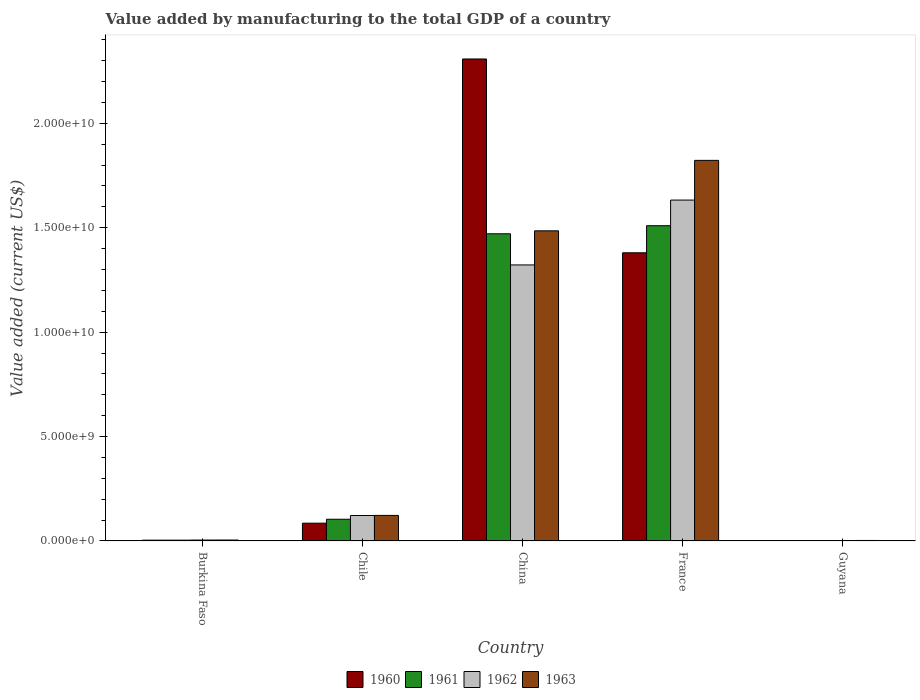How many different coloured bars are there?
Offer a terse response. 4. How many bars are there on the 5th tick from the left?
Your response must be concise. 4. How many bars are there on the 5th tick from the right?
Make the answer very short. 4. What is the label of the 1st group of bars from the left?
Provide a short and direct response. Burkina Faso. What is the value added by manufacturing to the total GDP in 1962 in Chile?
Your answer should be very brief. 1.22e+09. Across all countries, what is the maximum value added by manufacturing to the total GDP in 1963?
Your response must be concise. 1.82e+1. Across all countries, what is the minimum value added by manufacturing to the total GDP in 1963?
Provide a succinct answer. 2.32e+07. In which country was the value added by manufacturing to the total GDP in 1962 minimum?
Provide a short and direct response. Guyana. What is the total value added by manufacturing to the total GDP in 1960 in the graph?
Make the answer very short. 3.78e+1. What is the difference between the value added by manufacturing to the total GDP in 1960 in China and that in France?
Ensure brevity in your answer.  9.28e+09. What is the difference between the value added by manufacturing to the total GDP in 1961 in France and the value added by manufacturing to the total GDP in 1960 in China?
Ensure brevity in your answer.  -7.98e+09. What is the average value added by manufacturing to the total GDP in 1961 per country?
Keep it short and to the point. 6.18e+09. What is the difference between the value added by manufacturing to the total GDP of/in 1963 and value added by manufacturing to the total GDP of/in 1962 in Chile?
Offer a very short reply. 4.28e+06. In how many countries, is the value added by manufacturing to the total GDP in 1962 greater than 1000000000 US$?
Your answer should be very brief. 3. What is the ratio of the value added by manufacturing to the total GDP in 1963 in Chile to that in China?
Your answer should be compact. 0.08. What is the difference between the highest and the second highest value added by manufacturing to the total GDP in 1961?
Provide a succinct answer. -3.87e+08. What is the difference between the highest and the lowest value added by manufacturing to the total GDP in 1962?
Offer a terse response. 1.63e+1. In how many countries, is the value added by manufacturing to the total GDP in 1960 greater than the average value added by manufacturing to the total GDP in 1960 taken over all countries?
Keep it short and to the point. 2. Is the sum of the value added by manufacturing to the total GDP in 1963 in Chile and China greater than the maximum value added by manufacturing to the total GDP in 1960 across all countries?
Give a very brief answer. No. What does the 3rd bar from the right in Chile represents?
Your answer should be compact. 1961. How many bars are there?
Give a very brief answer. 20. Does the graph contain grids?
Provide a short and direct response. No. Where does the legend appear in the graph?
Ensure brevity in your answer.  Bottom center. What is the title of the graph?
Ensure brevity in your answer.  Value added by manufacturing to the total GDP of a country. What is the label or title of the X-axis?
Give a very brief answer. Country. What is the label or title of the Y-axis?
Give a very brief answer. Value added (current US$). What is the Value added (current US$) of 1960 in Burkina Faso?
Your answer should be very brief. 3.72e+07. What is the Value added (current US$) in 1961 in Burkina Faso?
Your response must be concise. 3.72e+07. What is the Value added (current US$) in 1962 in Burkina Faso?
Ensure brevity in your answer.  4.22e+07. What is the Value added (current US$) in 1963 in Burkina Faso?
Keep it short and to the point. 4.39e+07. What is the Value added (current US$) in 1960 in Chile?
Offer a terse response. 8.51e+08. What is the Value added (current US$) of 1961 in Chile?
Offer a terse response. 1.04e+09. What is the Value added (current US$) of 1962 in Chile?
Ensure brevity in your answer.  1.22e+09. What is the Value added (current US$) in 1963 in Chile?
Keep it short and to the point. 1.22e+09. What is the Value added (current US$) of 1960 in China?
Ensure brevity in your answer.  2.31e+1. What is the Value added (current US$) in 1961 in China?
Offer a very short reply. 1.47e+1. What is the Value added (current US$) in 1962 in China?
Ensure brevity in your answer.  1.32e+1. What is the Value added (current US$) in 1963 in China?
Provide a short and direct response. 1.49e+1. What is the Value added (current US$) in 1960 in France?
Offer a very short reply. 1.38e+1. What is the Value added (current US$) in 1961 in France?
Provide a short and direct response. 1.51e+1. What is the Value added (current US$) in 1962 in France?
Your answer should be very brief. 1.63e+1. What is the Value added (current US$) of 1963 in France?
Your answer should be very brief. 1.82e+1. What is the Value added (current US$) of 1960 in Guyana?
Your response must be concise. 1.59e+07. What is the Value added (current US$) of 1961 in Guyana?
Provide a succinct answer. 1.84e+07. What is the Value added (current US$) of 1962 in Guyana?
Your answer should be very brief. 2.08e+07. What is the Value added (current US$) of 1963 in Guyana?
Your answer should be compact. 2.32e+07. Across all countries, what is the maximum Value added (current US$) in 1960?
Your response must be concise. 2.31e+1. Across all countries, what is the maximum Value added (current US$) of 1961?
Give a very brief answer. 1.51e+1. Across all countries, what is the maximum Value added (current US$) in 1962?
Ensure brevity in your answer.  1.63e+1. Across all countries, what is the maximum Value added (current US$) of 1963?
Keep it short and to the point. 1.82e+1. Across all countries, what is the minimum Value added (current US$) in 1960?
Offer a terse response. 1.59e+07. Across all countries, what is the minimum Value added (current US$) in 1961?
Give a very brief answer. 1.84e+07. Across all countries, what is the minimum Value added (current US$) in 1962?
Keep it short and to the point. 2.08e+07. Across all countries, what is the minimum Value added (current US$) in 1963?
Your answer should be compact. 2.32e+07. What is the total Value added (current US$) in 1960 in the graph?
Provide a short and direct response. 3.78e+1. What is the total Value added (current US$) in 1961 in the graph?
Offer a very short reply. 3.09e+1. What is the total Value added (current US$) of 1962 in the graph?
Ensure brevity in your answer.  3.08e+1. What is the total Value added (current US$) of 1963 in the graph?
Provide a succinct answer. 3.44e+1. What is the difference between the Value added (current US$) in 1960 in Burkina Faso and that in Chile?
Offer a very short reply. -8.13e+08. What is the difference between the Value added (current US$) in 1961 in Burkina Faso and that in Chile?
Keep it short and to the point. -1.00e+09. What is the difference between the Value added (current US$) in 1962 in Burkina Faso and that in Chile?
Provide a succinct answer. -1.18e+09. What is the difference between the Value added (current US$) of 1963 in Burkina Faso and that in Chile?
Your answer should be compact. -1.18e+09. What is the difference between the Value added (current US$) of 1960 in Burkina Faso and that in China?
Provide a short and direct response. -2.30e+1. What is the difference between the Value added (current US$) in 1961 in Burkina Faso and that in China?
Provide a succinct answer. -1.47e+1. What is the difference between the Value added (current US$) in 1962 in Burkina Faso and that in China?
Provide a short and direct response. -1.32e+1. What is the difference between the Value added (current US$) of 1963 in Burkina Faso and that in China?
Your answer should be compact. -1.48e+1. What is the difference between the Value added (current US$) in 1960 in Burkina Faso and that in France?
Provide a succinct answer. -1.38e+1. What is the difference between the Value added (current US$) of 1961 in Burkina Faso and that in France?
Your answer should be very brief. -1.51e+1. What is the difference between the Value added (current US$) in 1962 in Burkina Faso and that in France?
Ensure brevity in your answer.  -1.63e+1. What is the difference between the Value added (current US$) of 1963 in Burkina Faso and that in France?
Provide a succinct answer. -1.82e+1. What is the difference between the Value added (current US$) of 1960 in Burkina Faso and that in Guyana?
Your answer should be compact. 2.14e+07. What is the difference between the Value added (current US$) of 1961 in Burkina Faso and that in Guyana?
Give a very brief answer. 1.88e+07. What is the difference between the Value added (current US$) in 1962 in Burkina Faso and that in Guyana?
Offer a terse response. 2.15e+07. What is the difference between the Value added (current US$) in 1963 in Burkina Faso and that in Guyana?
Ensure brevity in your answer.  2.07e+07. What is the difference between the Value added (current US$) of 1960 in Chile and that in China?
Provide a succinct answer. -2.22e+1. What is the difference between the Value added (current US$) of 1961 in Chile and that in China?
Your answer should be very brief. -1.37e+1. What is the difference between the Value added (current US$) of 1962 in Chile and that in China?
Your answer should be very brief. -1.20e+1. What is the difference between the Value added (current US$) of 1963 in Chile and that in China?
Your answer should be very brief. -1.36e+1. What is the difference between the Value added (current US$) in 1960 in Chile and that in France?
Ensure brevity in your answer.  -1.29e+1. What is the difference between the Value added (current US$) in 1961 in Chile and that in France?
Provide a short and direct response. -1.41e+1. What is the difference between the Value added (current US$) of 1962 in Chile and that in France?
Offer a terse response. -1.51e+1. What is the difference between the Value added (current US$) of 1963 in Chile and that in France?
Your answer should be very brief. -1.70e+1. What is the difference between the Value added (current US$) in 1960 in Chile and that in Guyana?
Give a very brief answer. 8.35e+08. What is the difference between the Value added (current US$) in 1961 in Chile and that in Guyana?
Give a very brief answer. 1.02e+09. What is the difference between the Value added (current US$) in 1962 in Chile and that in Guyana?
Offer a very short reply. 1.20e+09. What is the difference between the Value added (current US$) in 1963 in Chile and that in Guyana?
Your response must be concise. 1.20e+09. What is the difference between the Value added (current US$) in 1960 in China and that in France?
Provide a short and direct response. 9.28e+09. What is the difference between the Value added (current US$) of 1961 in China and that in France?
Provide a short and direct response. -3.87e+08. What is the difference between the Value added (current US$) of 1962 in China and that in France?
Your response must be concise. -3.11e+09. What is the difference between the Value added (current US$) in 1963 in China and that in France?
Ensure brevity in your answer.  -3.37e+09. What is the difference between the Value added (current US$) of 1960 in China and that in Guyana?
Your response must be concise. 2.31e+1. What is the difference between the Value added (current US$) of 1961 in China and that in Guyana?
Make the answer very short. 1.47e+1. What is the difference between the Value added (current US$) of 1962 in China and that in Guyana?
Keep it short and to the point. 1.32e+1. What is the difference between the Value added (current US$) of 1963 in China and that in Guyana?
Offer a terse response. 1.48e+1. What is the difference between the Value added (current US$) of 1960 in France and that in Guyana?
Provide a short and direct response. 1.38e+1. What is the difference between the Value added (current US$) in 1961 in France and that in Guyana?
Your answer should be compact. 1.51e+1. What is the difference between the Value added (current US$) in 1962 in France and that in Guyana?
Your answer should be compact. 1.63e+1. What is the difference between the Value added (current US$) in 1963 in France and that in Guyana?
Keep it short and to the point. 1.82e+1. What is the difference between the Value added (current US$) in 1960 in Burkina Faso and the Value added (current US$) in 1961 in Chile?
Ensure brevity in your answer.  -1.00e+09. What is the difference between the Value added (current US$) of 1960 in Burkina Faso and the Value added (current US$) of 1962 in Chile?
Provide a short and direct response. -1.18e+09. What is the difference between the Value added (current US$) in 1960 in Burkina Faso and the Value added (current US$) in 1963 in Chile?
Keep it short and to the point. -1.19e+09. What is the difference between the Value added (current US$) in 1961 in Burkina Faso and the Value added (current US$) in 1962 in Chile?
Provide a short and direct response. -1.18e+09. What is the difference between the Value added (current US$) in 1961 in Burkina Faso and the Value added (current US$) in 1963 in Chile?
Offer a very short reply. -1.19e+09. What is the difference between the Value added (current US$) of 1962 in Burkina Faso and the Value added (current US$) of 1963 in Chile?
Your answer should be very brief. -1.18e+09. What is the difference between the Value added (current US$) in 1960 in Burkina Faso and the Value added (current US$) in 1961 in China?
Provide a succinct answer. -1.47e+1. What is the difference between the Value added (current US$) of 1960 in Burkina Faso and the Value added (current US$) of 1962 in China?
Provide a short and direct response. -1.32e+1. What is the difference between the Value added (current US$) of 1960 in Burkina Faso and the Value added (current US$) of 1963 in China?
Give a very brief answer. -1.48e+1. What is the difference between the Value added (current US$) in 1961 in Burkina Faso and the Value added (current US$) in 1962 in China?
Offer a very short reply. -1.32e+1. What is the difference between the Value added (current US$) of 1961 in Burkina Faso and the Value added (current US$) of 1963 in China?
Provide a succinct answer. -1.48e+1. What is the difference between the Value added (current US$) of 1962 in Burkina Faso and the Value added (current US$) of 1963 in China?
Your response must be concise. -1.48e+1. What is the difference between the Value added (current US$) of 1960 in Burkina Faso and the Value added (current US$) of 1961 in France?
Make the answer very short. -1.51e+1. What is the difference between the Value added (current US$) in 1960 in Burkina Faso and the Value added (current US$) in 1962 in France?
Ensure brevity in your answer.  -1.63e+1. What is the difference between the Value added (current US$) of 1960 in Burkina Faso and the Value added (current US$) of 1963 in France?
Ensure brevity in your answer.  -1.82e+1. What is the difference between the Value added (current US$) in 1961 in Burkina Faso and the Value added (current US$) in 1962 in France?
Give a very brief answer. -1.63e+1. What is the difference between the Value added (current US$) of 1961 in Burkina Faso and the Value added (current US$) of 1963 in France?
Provide a short and direct response. -1.82e+1. What is the difference between the Value added (current US$) of 1962 in Burkina Faso and the Value added (current US$) of 1963 in France?
Your answer should be compact. -1.82e+1. What is the difference between the Value added (current US$) of 1960 in Burkina Faso and the Value added (current US$) of 1961 in Guyana?
Offer a very short reply. 1.89e+07. What is the difference between the Value added (current US$) of 1960 in Burkina Faso and the Value added (current US$) of 1962 in Guyana?
Your answer should be compact. 1.65e+07. What is the difference between the Value added (current US$) of 1960 in Burkina Faso and the Value added (current US$) of 1963 in Guyana?
Provide a succinct answer. 1.41e+07. What is the difference between the Value added (current US$) in 1961 in Burkina Faso and the Value added (current US$) in 1962 in Guyana?
Provide a short and direct response. 1.65e+07. What is the difference between the Value added (current US$) of 1961 in Burkina Faso and the Value added (current US$) of 1963 in Guyana?
Make the answer very short. 1.41e+07. What is the difference between the Value added (current US$) of 1962 in Burkina Faso and the Value added (current US$) of 1963 in Guyana?
Your response must be concise. 1.91e+07. What is the difference between the Value added (current US$) in 1960 in Chile and the Value added (current US$) in 1961 in China?
Your response must be concise. -1.39e+1. What is the difference between the Value added (current US$) in 1960 in Chile and the Value added (current US$) in 1962 in China?
Provide a succinct answer. -1.24e+1. What is the difference between the Value added (current US$) of 1960 in Chile and the Value added (current US$) of 1963 in China?
Your answer should be compact. -1.40e+1. What is the difference between the Value added (current US$) in 1961 in Chile and the Value added (current US$) in 1962 in China?
Offer a terse response. -1.22e+1. What is the difference between the Value added (current US$) in 1961 in Chile and the Value added (current US$) in 1963 in China?
Your response must be concise. -1.38e+1. What is the difference between the Value added (current US$) of 1962 in Chile and the Value added (current US$) of 1963 in China?
Give a very brief answer. -1.36e+1. What is the difference between the Value added (current US$) of 1960 in Chile and the Value added (current US$) of 1961 in France?
Your answer should be compact. -1.42e+1. What is the difference between the Value added (current US$) of 1960 in Chile and the Value added (current US$) of 1962 in France?
Keep it short and to the point. -1.55e+1. What is the difference between the Value added (current US$) in 1960 in Chile and the Value added (current US$) in 1963 in France?
Make the answer very short. -1.74e+1. What is the difference between the Value added (current US$) in 1961 in Chile and the Value added (current US$) in 1962 in France?
Keep it short and to the point. -1.53e+1. What is the difference between the Value added (current US$) of 1961 in Chile and the Value added (current US$) of 1963 in France?
Your answer should be very brief. -1.72e+1. What is the difference between the Value added (current US$) of 1962 in Chile and the Value added (current US$) of 1963 in France?
Provide a short and direct response. -1.70e+1. What is the difference between the Value added (current US$) in 1960 in Chile and the Value added (current US$) in 1961 in Guyana?
Provide a short and direct response. 8.32e+08. What is the difference between the Value added (current US$) of 1960 in Chile and the Value added (current US$) of 1962 in Guyana?
Your answer should be compact. 8.30e+08. What is the difference between the Value added (current US$) in 1960 in Chile and the Value added (current US$) in 1963 in Guyana?
Give a very brief answer. 8.28e+08. What is the difference between the Value added (current US$) of 1961 in Chile and the Value added (current US$) of 1962 in Guyana?
Your answer should be very brief. 1.02e+09. What is the difference between the Value added (current US$) of 1961 in Chile and the Value added (current US$) of 1963 in Guyana?
Your answer should be very brief. 1.02e+09. What is the difference between the Value added (current US$) in 1962 in Chile and the Value added (current US$) in 1963 in Guyana?
Provide a succinct answer. 1.20e+09. What is the difference between the Value added (current US$) of 1960 in China and the Value added (current US$) of 1961 in France?
Keep it short and to the point. 7.98e+09. What is the difference between the Value added (current US$) in 1960 in China and the Value added (current US$) in 1962 in France?
Provide a succinct answer. 6.76e+09. What is the difference between the Value added (current US$) of 1960 in China and the Value added (current US$) of 1963 in France?
Give a very brief answer. 4.86e+09. What is the difference between the Value added (current US$) in 1961 in China and the Value added (current US$) in 1962 in France?
Ensure brevity in your answer.  -1.61e+09. What is the difference between the Value added (current US$) in 1961 in China and the Value added (current US$) in 1963 in France?
Your answer should be compact. -3.52e+09. What is the difference between the Value added (current US$) in 1962 in China and the Value added (current US$) in 1963 in France?
Provide a short and direct response. -5.01e+09. What is the difference between the Value added (current US$) of 1960 in China and the Value added (current US$) of 1961 in Guyana?
Keep it short and to the point. 2.31e+1. What is the difference between the Value added (current US$) of 1960 in China and the Value added (current US$) of 1962 in Guyana?
Provide a succinct answer. 2.31e+1. What is the difference between the Value added (current US$) of 1960 in China and the Value added (current US$) of 1963 in Guyana?
Keep it short and to the point. 2.31e+1. What is the difference between the Value added (current US$) of 1961 in China and the Value added (current US$) of 1962 in Guyana?
Make the answer very short. 1.47e+1. What is the difference between the Value added (current US$) in 1961 in China and the Value added (current US$) in 1963 in Guyana?
Your answer should be compact. 1.47e+1. What is the difference between the Value added (current US$) in 1962 in China and the Value added (current US$) in 1963 in Guyana?
Offer a terse response. 1.32e+1. What is the difference between the Value added (current US$) of 1960 in France and the Value added (current US$) of 1961 in Guyana?
Your response must be concise. 1.38e+1. What is the difference between the Value added (current US$) in 1960 in France and the Value added (current US$) in 1962 in Guyana?
Provide a succinct answer. 1.38e+1. What is the difference between the Value added (current US$) in 1960 in France and the Value added (current US$) in 1963 in Guyana?
Ensure brevity in your answer.  1.38e+1. What is the difference between the Value added (current US$) in 1961 in France and the Value added (current US$) in 1962 in Guyana?
Make the answer very short. 1.51e+1. What is the difference between the Value added (current US$) of 1961 in France and the Value added (current US$) of 1963 in Guyana?
Provide a short and direct response. 1.51e+1. What is the difference between the Value added (current US$) in 1962 in France and the Value added (current US$) in 1963 in Guyana?
Your response must be concise. 1.63e+1. What is the average Value added (current US$) in 1960 per country?
Offer a terse response. 7.56e+09. What is the average Value added (current US$) in 1961 per country?
Offer a very short reply. 6.18e+09. What is the average Value added (current US$) of 1962 per country?
Offer a very short reply. 6.16e+09. What is the average Value added (current US$) in 1963 per country?
Your answer should be compact. 6.87e+09. What is the difference between the Value added (current US$) of 1960 and Value added (current US$) of 1961 in Burkina Faso?
Make the answer very short. 9866.11. What is the difference between the Value added (current US$) in 1960 and Value added (current US$) in 1962 in Burkina Faso?
Your answer should be compact. -5.00e+06. What is the difference between the Value added (current US$) of 1960 and Value added (current US$) of 1963 in Burkina Faso?
Provide a short and direct response. -6.65e+06. What is the difference between the Value added (current US$) in 1961 and Value added (current US$) in 1962 in Burkina Faso?
Provide a short and direct response. -5.01e+06. What is the difference between the Value added (current US$) of 1961 and Value added (current US$) of 1963 in Burkina Faso?
Keep it short and to the point. -6.66e+06. What is the difference between the Value added (current US$) in 1962 and Value added (current US$) in 1963 in Burkina Faso?
Offer a terse response. -1.65e+06. What is the difference between the Value added (current US$) in 1960 and Value added (current US$) in 1961 in Chile?
Your answer should be compact. -1.88e+08. What is the difference between the Value added (current US$) of 1960 and Value added (current US$) of 1962 in Chile?
Your answer should be very brief. -3.68e+08. What is the difference between the Value added (current US$) of 1960 and Value added (current US$) of 1963 in Chile?
Make the answer very short. -3.72e+08. What is the difference between the Value added (current US$) of 1961 and Value added (current US$) of 1962 in Chile?
Make the answer very short. -1.80e+08. What is the difference between the Value added (current US$) of 1961 and Value added (current US$) of 1963 in Chile?
Offer a terse response. -1.84e+08. What is the difference between the Value added (current US$) of 1962 and Value added (current US$) of 1963 in Chile?
Offer a terse response. -4.28e+06. What is the difference between the Value added (current US$) of 1960 and Value added (current US$) of 1961 in China?
Your response must be concise. 8.37e+09. What is the difference between the Value added (current US$) in 1960 and Value added (current US$) in 1962 in China?
Make the answer very short. 9.86e+09. What is the difference between the Value added (current US$) of 1960 and Value added (current US$) of 1963 in China?
Give a very brief answer. 8.23e+09. What is the difference between the Value added (current US$) of 1961 and Value added (current US$) of 1962 in China?
Make the answer very short. 1.49e+09. What is the difference between the Value added (current US$) in 1961 and Value added (current US$) in 1963 in China?
Your answer should be compact. -1.42e+08. What is the difference between the Value added (current US$) of 1962 and Value added (current US$) of 1963 in China?
Make the answer very short. -1.63e+09. What is the difference between the Value added (current US$) in 1960 and Value added (current US$) in 1961 in France?
Keep it short and to the point. -1.30e+09. What is the difference between the Value added (current US$) of 1960 and Value added (current US$) of 1962 in France?
Offer a very short reply. -2.52e+09. What is the difference between the Value added (current US$) of 1960 and Value added (current US$) of 1963 in France?
Your response must be concise. -4.43e+09. What is the difference between the Value added (current US$) in 1961 and Value added (current US$) in 1962 in France?
Offer a terse response. -1.23e+09. What is the difference between the Value added (current US$) in 1961 and Value added (current US$) in 1963 in France?
Your answer should be compact. -3.13e+09. What is the difference between the Value added (current US$) in 1962 and Value added (current US$) in 1963 in France?
Give a very brief answer. -1.90e+09. What is the difference between the Value added (current US$) of 1960 and Value added (current US$) of 1961 in Guyana?
Ensure brevity in your answer.  -2.51e+06. What is the difference between the Value added (current US$) of 1960 and Value added (current US$) of 1962 in Guyana?
Your response must be concise. -4.90e+06. What is the difference between the Value added (current US$) in 1960 and Value added (current US$) in 1963 in Guyana?
Keep it short and to the point. -7.29e+06. What is the difference between the Value added (current US$) of 1961 and Value added (current US$) of 1962 in Guyana?
Your answer should be very brief. -2.39e+06. What is the difference between the Value added (current US$) of 1961 and Value added (current US$) of 1963 in Guyana?
Your answer should be compact. -4.78e+06. What is the difference between the Value added (current US$) in 1962 and Value added (current US$) in 1963 in Guyana?
Make the answer very short. -2.39e+06. What is the ratio of the Value added (current US$) in 1960 in Burkina Faso to that in Chile?
Give a very brief answer. 0.04. What is the ratio of the Value added (current US$) of 1961 in Burkina Faso to that in Chile?
Make the answer very short. 0.04. What is the ratio of the Value added (current US$) in 1962 in Burkina Faso to that in Chile?
Make the answer very short. 0.03. What is the ratio of the Value added (current US$) in 1963 in Burkina Faso to that in Chile?
Your answer should be compact. 0.04. What is the ratio of the Value added (current US$) in 1960 in Burkina Faso to that in China?
Your answer should be compact. 0. What is the ratio of the Value added (current US$) of 1961 in Burkina Faso to that in China?
Provide a short and direct response. 0. What is the ratio of the Value added (current US$) in 1962 in Burkina Faso to that in China?
Your response must be concise. 0. What is the ratio of the Value added (current US$) of 1963 in Burkina Faso to that in China?
Give a very brief answer. 0. What is the ratio of the Value added (current US$) in 1960 in Burkina Faso to that in France?
Make the answer very short. 0. What is the ratio of the Value added (current US$) in 1961 in Burkina Faso to that in France?
Provide a short and direct response. 0. What is the ratio of the Value added (current US$) in 1962 in Burkina Faso to that in France?
Your answer should be compact. 0. What is the ratio of the Value added (current US$) in 1963 in Burkina Faso to that in France?
Provide a short and direct response. 0. What is the ratio of the Value added (current US$) of 1960 in Burkina Faso to that in Guyana?
Keep it short and to the point. 2.35. What is the ratio of the Value added (current US$) in 1961 in Burkina Faso to that in Guyana?
Provide a short and direct response. 2.03. What is the ratio of the Value added (current US$) in 1962 in Burkina Faso to that in Guyana?
Offer a terse response. 2.03. What is the ratio of the Value added (current US$) in 1963 in Burkina Faso to that in Guyana?
Your response must be concise. 1.89. What is the ratio of the Value added (current US$) in 1960 in Chile to that in China?
Your answer should be very brief. 0.04. What is the ratio of the Value added (current US$) in 1961 in Chile to that in China?
Ensure brevity in your answer.  0.07. What is the ratio of the Value added (current US$) in 1962 in Chile to that in China?
Your response must be concise. 0.09. What is the ratio of the Value added (current US$) of 1963 in Chile to that in China?
Give a very brief answer. 0.08. What is the ratio of the Value added (current US$) in 1960 in Chile to that in France?
Offer a terse response. 0.06. What is the ratio of the Value added (current US$) of 1961 in Chile to that in France?
Provide a succinct answer. 0.07. What is the ratio of the Value added (current US$) of 1962 in Chile to that in France?
Give a very brief answer. 0.07. What is the ratio of the Value added (current US$) in 1963 in Chile to that in France?
Give a very brief answer. 0.07. What is the ratio of the Value added (current US$) in 1960 in Chile to that in Guyana?
Keep it short and to the point. 53.62. What is the ratio of the Value added (current US$) in 1961 in Chile to that in Guyana?
Offer a terse response. 56.53. What is the ratio of the Value added (current US$) of 1962 in Chile to that in Guyana?
Give a very brief answer. 58.67. What is the ratio of the Value added (current US$) in 1963 in Chile to that in Guyana?
Make the answer very short. 52.79. What is the ratio of the Value added (current US$) in 1960 in China to that in France?
Your answer should be very brief. 1.67. What is the ratio of the Value added (current US$) in 1961 in China to that in France?
Give a very brief answer. 0.97. What is the ratio of the Value added (current US$) in 1962 in China to that in France?
Ensure brevity in your answer.  0.81. What is the ratio of the Value added (current US$) in 1963 in China to that in France?
Keep it short and to the point. 0.81. What is the ratio of the Value added (current US$) in 1960 in China to that in Guyana?
Your answer should be compact. 1454.66. What is the ratio of the Value added (current US$) of 1961 in China to that in Guyana?
Make the answer very short. 800.48. What is the ratio of the Value added (current US$) of 1962 in China to that in Guyana?
Make the answer very short. 636.5. What is the ratio of the Value added (current US$) in 1963 in China to that in Guyana?
Ensure brevity in your answer.  641.28. What is the ratio of the Value added (current US$) of 1960 in France to that in Guyana?
Ensure brevity in your answer.  869.7. What is the ratio of the Value added (current US$) of 1961 in France to that in Guyana?
Give a very brief answer. 821.55. What is the ratio of the Value added (current US$) in 1962 in France to that in Guyana?
Provide a short and direct response. 786.05. What is the ratio of the Value added (current US$) in 1963 in France to that in Guyana?
Offer a very short reply. 786.97. What is the difference between the highest and the second highest Value added (current US$) of 1960?
Your answer should be compact. 9.28e+09. What is the difference between the highest and the second highest Value added (current US$) of 1961?
Make the answer very short. 3.87e+08. What is the difference between the highest and the second highest Value added (current US$) in 1962?
Your answer should be very brief. 3.11e+09. What is the difference between the highest and the second highest Value added (current US$) of 1963?
Ensure brevity in your answer.  3.37e+09. What is the difference between the highest and the lowest Value added (current US$) in 1960?
Give a very brief answer. 2.31e+1. What is the difference between the highest and the lowest Value added (current US$) of 1961?
Make the answer very short. 1.51e+1. What is the difference between the highest and the lowest Value added (current US$) of 1962?
Make the answer very short. 1.63e+1. What is the difference between the highest and the lowest Value added (current US$) of 1963?
Provide a succinct answer. 1.82e+1. 